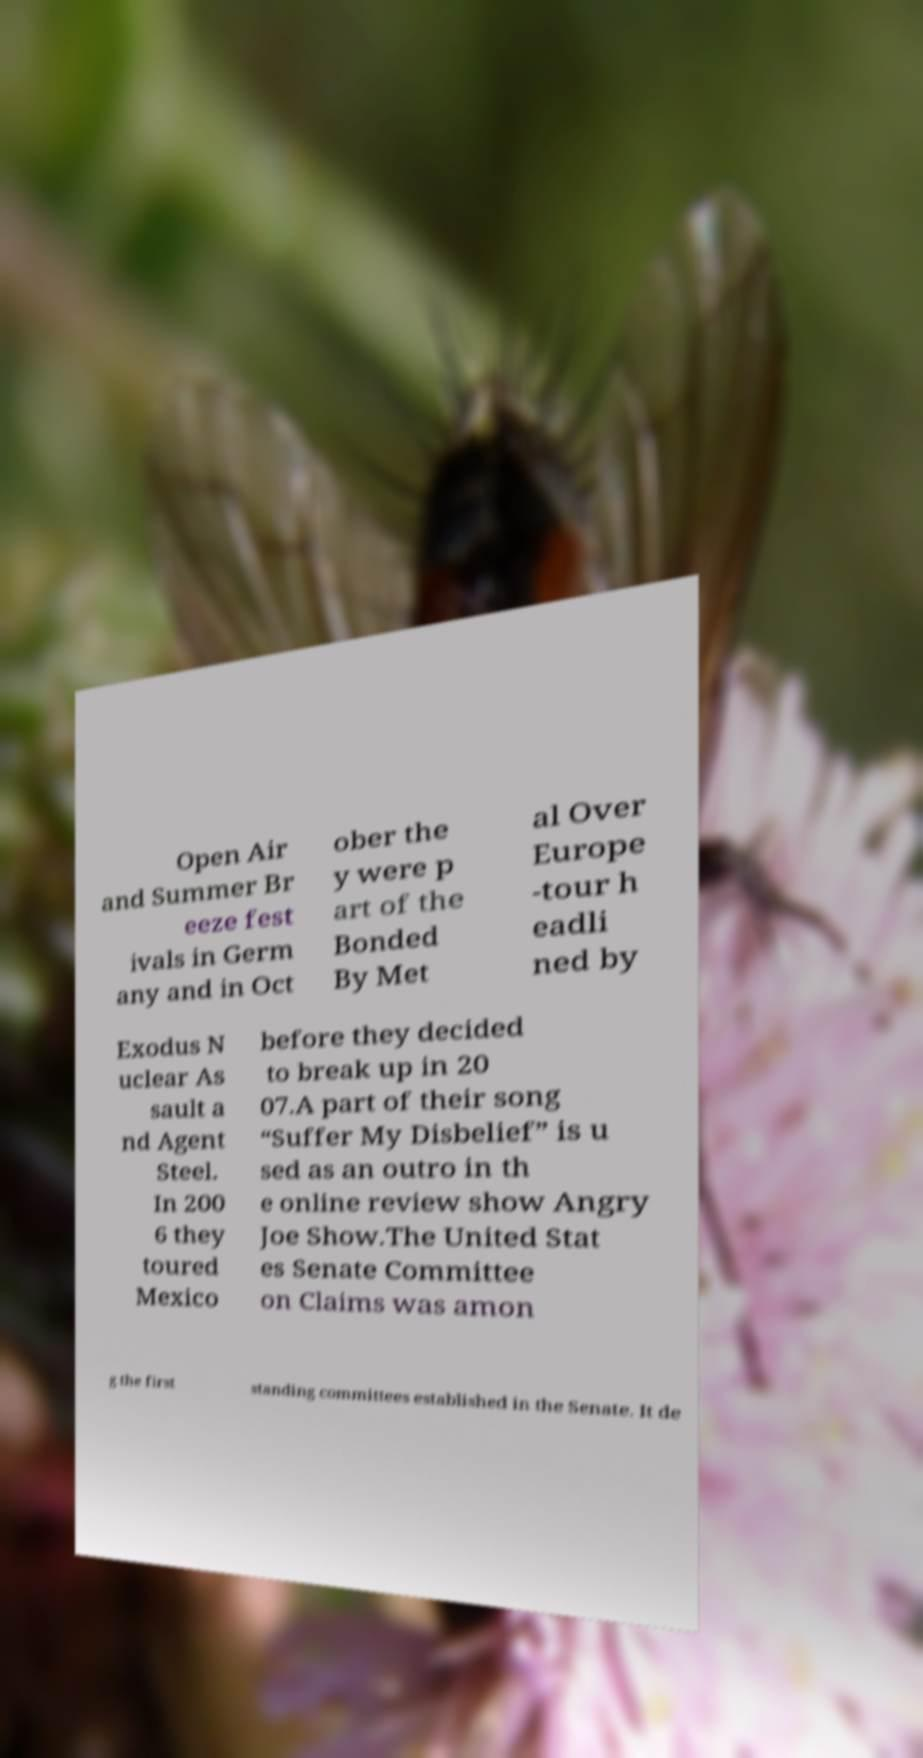Could you extract and type out the text from this image? Open Air and Summer Br eeze fest ivals in Germ any and in Oct ober the y were p art of the Bonded By Met al Over Europe -tour h eadli ned by Exodus N uclear As sault a nd Agent Steel. In 200 6 they toured Mexico before they decided to break up in 20 07.A part of their song “Suffer My Disbelief” is u sed as an outro in th e online review show Angry Joe Show.The United Stat es Senate Committee on Claims was amon g the first standing committees established in the Senate. It de 